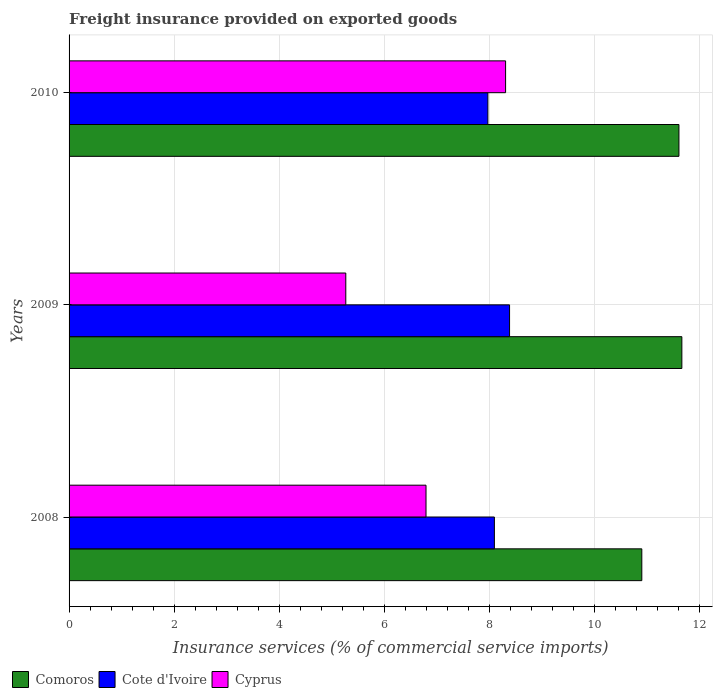How many different coloured bars are there?
Offer a very short reply. 3. How many groups of bars are there?
Give a very brief answer. 3. Are the number of bars per tick equal to the number of legend labels?
Your answer should be compact. Yes. How many bars are there on the 3rd tick from the top?
Your answer should be very brief. 3. How many bars are there on the 2nd tick from the bottom?
Give a very brief answer. 3. In how many cases, is the number of bars for a given year not equal to the number of legend labels?
Make the answer very short. 0. What is the freight insurance provided on exported goods in Cote d'Ivoire in 2008?
Your response must be concise. 8.09. Across all years, what is the maximum freight insurance provided on exported goods in Cyprus?
Keep it short and to the point. 8.31. Across all years, what is the minimum freight insurance provided on exported goods in Comoros?
Give a very brief answer. 10.9. In which year was the freight insurance provided on exported goods in Comoros maximum?
Provide a short and direct response. 2009. What is the total freight insurance provided on exported goods in Cyprus in the graph?
Make the answer very short. 20.36. What is the difference between the freight insurance provided on exported goods in Cote d'Ivoire in 2008 and that in 2010?
Ensure brevity in your answer.  0.12. What is the difference between the freight insurance provided on exported goods in Cyprus in 2010 and the freight insurance provided on exported goods in Comoros in 2009?
Your answer should be very brief. -3.35. What is the average freight insurance provided on exported goods in Cote d'Ivoire per year?
Offer a very short reply. 8.15. In the year 2008, what is the difference between the freight insurance provided on exported goods in Cote d'Ivoire and freight insurance provided on exported goods in Comoros?
Your answer should be very brief. -2.81. In how many years, is the freight insurance provided on exported goods in Comoros greater than 5.6 %?
Your answer should be very brief. 3. What is the ratio of the freight insurance provided on exported goods in Comoros in 2008 to that in 2009?
Your answer should be compact. 0.93. What is the difference between the highest and the second highest freight insurance provided on exported goods in Cote d'Ivoire?
Provide a short and direct response. 0.29. What is the difference between the highest and the lowest freight insurance provided on exported goods in Comoros?
Provide a short and direct response. 0.76. In how many years, is the freight insurance provided on exported goods in Comoros greater than the average freight insurance provided on exported goods in Comoros taken over all years?
Your answer should be very brief. 2. What does the 3rd bar from the top in 2009 represents?
Provide a succinct answer. Comoros. What does the 3rd bar from the bottom in 2009 represents?
Offer a terse response. Cyprus. How many bars are there?
Offer a very short reply. 9. How many years are there in the graph?
Your response must be concise. 3. Are the values on the major ticks of X-axis written in scientific E-notation?
Give a very brief answer. No. Does the graph contain any zero values?
Your response must be concise. No. Does the graph contain grids?
Offer a terse response. Yes. Where does the legend appear in the graph?
Give a very brief answer. Bottom left. How many legend labels are there?
Provide a succinct answer. 3. What is the title of the graph?
Your answer should be compact. Freight insurance provided on exported goods. Does "Small states" appear as one of the legend labels in the graph?
Offer a terse response. No. What is the label or title of the X-axis?
Provide a succinct answer. Insurance services (% of commercial service imports). What is the label or title of the Y-axis?
Provide a succinct answer. Years. What is the Insurance services (% of commercial service imports) in Comoros in 2008?
Ensure brevity in your answer.  10.9. What is the Insurance services (% of commercial service imports) of Cote d'Ivoire in 2008?
Your answer should be very brief. 8.09. What is the Insurance services (% of commercial service imports) in Cyprus in 2008?
Keep it short and to the point. 6.79. What is the Insurance services (% of commercial service imports) in Comoros in 2009?
Keep it short and to the point. 11.66. What is the Insurance services (% of commercial service imports) in Cote d'Ivoire in 2009?
Your answer should be very brief. 8.38. What is the Insurance services (% of commercial service imports) in Cyprus in 2009?
Your response must be concise. 5.27. What is the Insurance services (% of commercial service imports) in Comoros in 2010?
Your answer should be compact. 11.6. What is the Insurance services (% of commercial service imports) in Cote d'Ivoire in 2010?
Your answer should be very brief. 7.97. What is the Insurance services (% of commercial service imports) of Cyprus in 2010?
Keep it short and to the point. 8.31. Across all years, what is the maximum Insurance services (% of commercial service imports) in Comoros?
Keep it short and to the point. 11.66. Across all years, what is the maximum Insurance services (% of commercial service imports) in Cote d'Ivoire?
Provide a short and direct response. 8.38. Across all years, what is the maximum Insurance services (% of commercial service imports) of Cyprus?
Offer a terse response. 8.31. Across all years, what is the minimum Insurance services (% of commercial service imports) of Comoros?
Your answer should be very brief. 10.9. Across all years, what is the minimum Insurance services (% of commercial service imports) of Cote d'Ivoire?
Provide a short and direct response. 7.97. Across all years, what is the minimum Insurance services (% of commercial service imports) in Cyprus?
Make the answer very short. 5.27. What is the total Insurance services (% of commercial service imports) of Comoros in the graph?
Offer a very short reply. 34.16. What is the total Insurance services (% of commercial service imports) of Cote d'Ivoire in the graph?
Your answer should be very brief. 24.44. What is the total Insurance services (% of commercial service imports) of Cyprus in the graph?
Your answer should be compact. 20.36. What is the difference between the Insurance services (% of commercial service imports) in Comoros in 2008 and that in 2009?
Provide a succinct answer. -0.76. What is the difference between the Insurance services (% of commercial service imports) of Cote d'Ivoire in 2008 and that in 2009?
Offer a terse response. -0.29. What is the difference between the Insurance services (% of commercial service imports) of Cyprus in 2008 and that in 2009?
Your response must be concise. 1.53. What is the difference between the Insurance services (% of commercial service imports) in Comoros in 2008 and that in 2010?
Provide a succinct answer. -0.71. What is the difference between the Insurance services (% of commercial service imports) of Cote d'Ivoire in 2008 and that in 2010?
Your answer should be very brief. 0.12. What is the difference between the Insurance services (% of commercial service imports) in Cyprus in 2008 and that in 2010?
Keep it short and to the point. -1.51. What is the difference between the Insurance services (% of commercial service imports) in Comoros in 2009 and that in 2010?
Provide a succinct answer. 0.06. What is the difference between the Insurance services (% of commercial service imports) of Cote d'Ivoire in 2009 and that in 2010?
Your response must be concise. 0.41. What is the difference between the Insurance services (% of commercial service imports) of Cyprus in 2009 and that in 2010?
Give a very brief answer. -3.04. What is the difference between the Insurance services (% of commercial service imports) in Comoros in 2008 and the Insurance services (% of commercial service imports) in Cote d'Ivoire in 2009?
Offer a terse response. 2.52. What is the difference between the Insurance services (% of commercial service imports) in Comoros in 2008 and the Insurance services (% of commercial service imports) in Cyprus in 2009?
Offer a very short reply. 5.63. What is the difference between the Insurance services (% of commercial service imports) of Cote d'Ivoire in 2008 and the Insurance services (% of commercial service imports) of Cyprus in 2009?
Offer a very short reply. 2.83. What is the difference between the Insurance services (% of commercial service imports) of Comoros in 2008 and the Insurance services (% of commercial service imports) of Cote d'Ivoire in 2010?
Provide a short and direct response. 2.93. What is the difference between the Insurance services (% of commercial service imports) of Comoros in 2008 and the Insurance services (% of commercial service imports) of Cyprus in 2010?
Ensure brevity in your answer.  2.59. What is the difference between the Insurance services (% of commercial service imports) in Cote d'Ivoire in 2008 and the Insurance services (% of commercial service imports) in Cyprus in 2010?
Your answer should be compact. -0.21. What is the difference between the Insurance services (% of commercial service imports) in Comoros in 2009 and the Insurance services (% of commercial service imports) in Cote d'Ivoire in 2010?
Your answer should be very brief. 3.69. What is the difference between the Insurance services (% of commercial service imports) of Comoros in 2009 and the Insurance services (% of commercial service imports) of Cyprus in 2010?
Provide a succinct answer. 3.35. What is the difference between the Insurance services (% of commercial service imports) of Cote d'Ivoire in 2009 and the Insurance services (% of commercial service imports) of Cyprus in 2010?
Offer a terse response. 0.08. What is the average Insurance services (% of commercial service imports) of Comoros per year?
Your answer should be very brief. 11.39. What is the average Insurance services (% of commercial service imports) in Cote d'Ivoire per year?
Provide a short and direct response. 8.15. What is the average Insurance services (% of commercial service imports) in Cyprus per year?
Make the answer very short. 6.79. In the year 2008, what is the difference between the Insurance services (% of commercial service imports) of Comoros and Insurance services (% of commercial service imports) of Cote d'Ivoire?
Provide a succinct answer. 2.81. In the year 2008, what is the difference between the Insurance services (% of commercial service imports) of Comoros and Insurance services (% of commercial service imports) of Cyprus?
Offer a terse response. 4.11. In the year 2008, what is the difference between the Insurance services (% of commercial service imports) of Cote d'Ivoire and Insurance services (% of commercial service imports) of Cyprus?
Ensure brevity in your answer.  1.3. In the year 2009, what is the difference between the Insurance services (% of commercial service imports) in Comoros and Insurance services (% of commercial service imports) in Cote d'Ivoire?
Offer a terse response. 3.28. In the year 2009, what is the difference between the Insurance services (% of commercial service imports) in Comoros and Insurance services (% of commercial service imports) in Cyprus?
Offer a very short reply. 6.39. In the year 2009, what is the difference between the Insurance services (% of commercial service imports) in Cote d'Ivoire and Insurance services (% of commercial service imports) in Cyprus?
Provide a succinct answer. 3.12. In the year 2010, what is the difference between the Insurance services (% of commercial service imports) of Comoros and Insurance services (% of commercial service imports) of Cote d'Ivoire?
Offer a terse response. 3.63. In the year 2010, what is the difference between the Insurance services (% of commercial service imports) in Comoros and Insurance services (% of commercial service imports) in Cyprus?
Provide a short and direct response. 3.3. In the year 2010, what is the difference between the Insurance services (% of commercial service imports) of Cote d'Ivoire and Insurance services (% of commercial service imports) of Cyprus?
Your response must be concise. -0.34. What is the ratio of the Insurance services (% of commercial service imports) of Comoros in 2008 to that in 2009?
Your response must be concise. 0.93. What is the ratio of the Insurance services (% of commercial service imports) in Cote d'Ivoire in 2008 to that in 2009?
Provide a succinct answer. 0.97. What is the ratio of the Insurance services (% of commercial service imports) of Cyprus in 2008 to that in 2009?
Give a very brief answer. 1.29. What is the ratio of the Insurance services (% of commercial service imports) in Comoros in 2008 to that in 2010?
Your answer should be very brief. 0.94. What is the ratio of the Insurance services (% of commercial service imports) of Cote d'Ivoire in 2008 to that in 2010?
Your answer should be very brief. 1.02. What is the ratio of the Insurance services (% of commercial service imports) of Cyprus in 2008 to that in 2010?
Your answer should be compact. 0.82. What is the ratio of the Insurance services (% of commercial service imports) of Cote d'Ivoire in 2009 to that in 2010?
Provide a short and direct response. 1.05. What is the ratio of the Insurance services (% of commercial service imports) in Cyprus in 2009 to that in 2010?
Make the answer very short. 0.63. What is the difference between the highest and the second highest Insurance services (% of commercial service imports) in Comoros?
Make the answer very short. 0.06. What is the difference between the highest and the second highest Insurance services (% of commercial service imports) of Cote d'Ivoire?
Offer a very short reply. 0.29. What is the difference between the highest and the second highest Insurance services (% of commercial service imports) in Cyprus?
Your response must be concise. 1.51. What is the difference between the highest and the lowest Insurance services (% of commercial service imports) of Comoros?
Give a very brief answer. 0.76. What is the difference between the highest and the lowest Insurance services (% of commercial service imports) in Cote d'Ivoire?
Your response must be concise. 0.41. What is the difference between the highest and the lowest Insurance services (% of commercial service imports) of Cyprus?
Your answer should be compact. 3.04. 